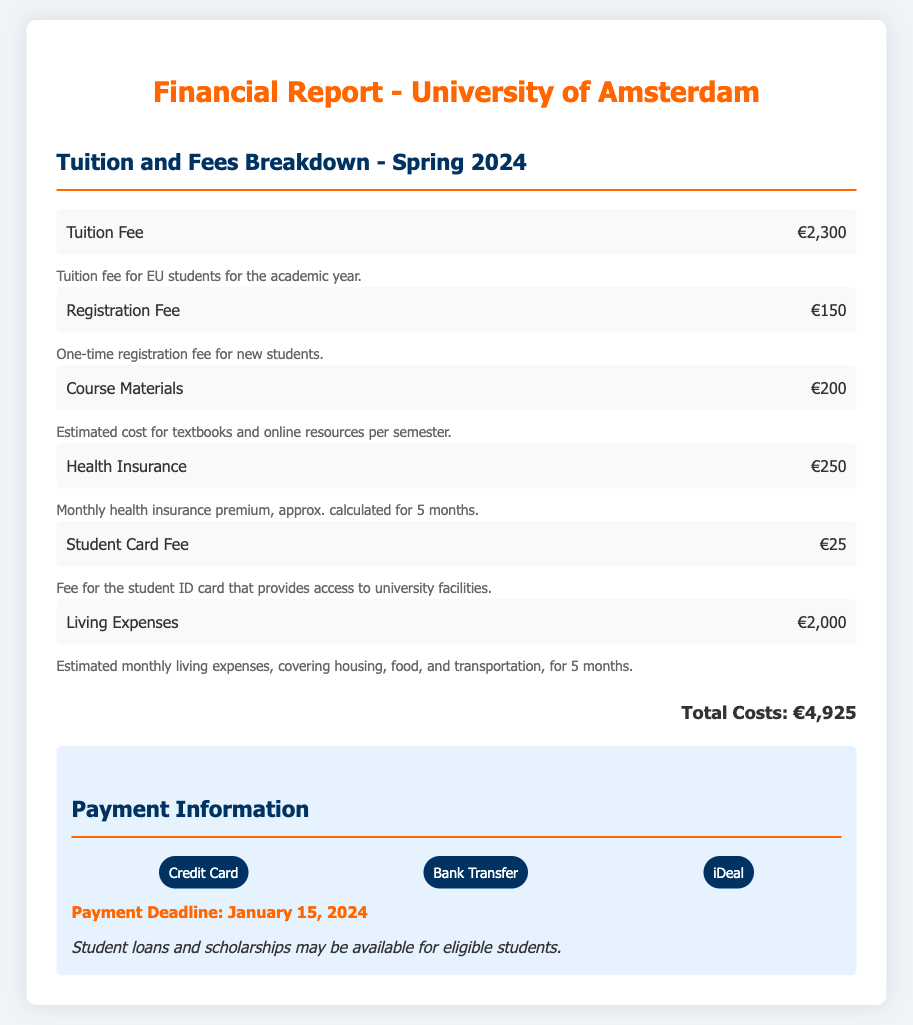what is the total cost for the semester? The total cost is clearly stated at the end of the document, summing up all specified costs.
Answer: €4,925 how much is the tuition fee for EU students? The tuition fee for EU students is listed in the document, which specifies the amount.
Answer: €2,300 what is the registration fee? The registration fee is indicated in the document as a specific cost for new students.
Answer: €150 how much are estimated living expenses? The document provides an estimate for living expenses, combining various necessities for a specified duration.
Answer: €2,000 when is the payment deadline? The payment deadline is provided explicitly at the end of the section discussing payment information.
Answer: January 15, 2024 what is the health insurance cost? The document states the health insurance cost, offering a detailed breakdown of expected expenses.
Answer: €250 what types of payment methods are accepted? The document lists the accepted payment methods, which are specifically mentioned in a section about payment information.
Answer: Credit Card, Bank Transfer, iDeal how much is the student card fee? The student card fee is detailed in the breakdown of costs for the semester, providing clarity on this specific expense.
Answer: €25 how long is the health insurance premium calculated for? The document explains the calculation of the health insurance premium in months, detailing its duration.
Answer: 5 months 